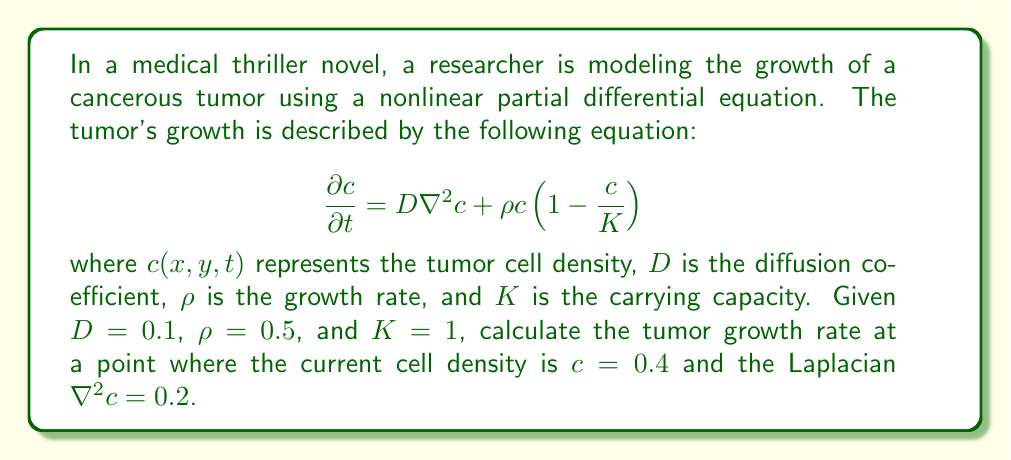What is the answer to this math problem? To solve this problem, we need to follow these steps:

1) The given equation is a reaction-diffusion equation, specifically a Fisher-KPP equation, which is commonly used to model tumor growth.

2) We're asked to calculate $\frac{\partial c}{\partial t}$, which represents the tumor growth rate.

3) We're given the following values:
   $D = 0.1$
   $\rho = 0.5$
   $K = 1$
   $c = 0.4$
   $\nabla^2c = 0.2$

4) Let's substitute these values into the equation:

   $$\frac{\partial c}{\partial t} = D\nabla^2c + \rho c(1-\frac{c}{K})$$

5) First, let's calculate the diffusion term:
   $D\nabla^2c = 0.1 \times 0.2 = 0.02$

6) Now, let's calculate the reaction term:
   $\rho c(1-\frac{c}{K}) = 0.5 \times 0.4 \times (1-\frac{0.4}{1}) = 0.5 \times 0.4 \times 0.6 = 0.12$

7) Finally, we sum these terms:
   $\frac{\partial c}{\partial t} = 0.02 + 0.12 = 0.14$

Therefore, the tumor growth rate at the given point is 0.14.
Answer: $\frac{\partial c}{\partial t} = 0.14$ 